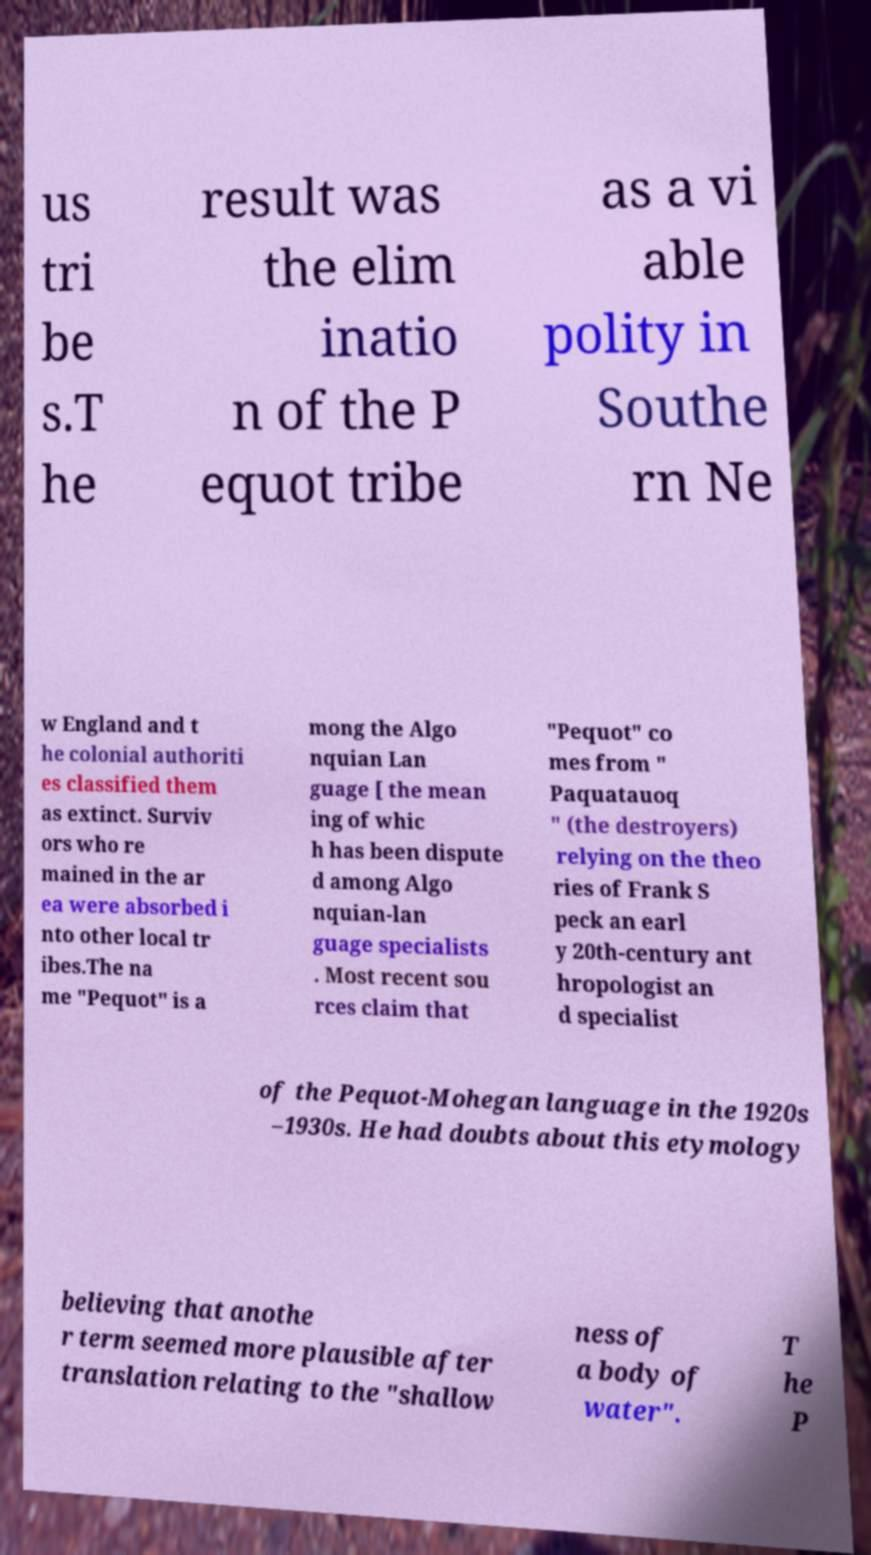There's text embedded in this image that I need extracted. Can you transcribe it verbatim? us tri be s.T he result was the elim inatio n of the P equot tribe as a vi able polity in Southe rn Ne w England and t he colonial authoriti es classified them as extinct. Surviv ors who re mained in the ar ea were absorbed i nto other local tr ibes.The na me "Pequot" is a mong the Algo nquian Lan guage [ the mean ing of whic h has been dispute d among Algo nquian-lan guage specialists . Most recent sou rces claim that "Pequot" co mes from " Paquatauoq " (the destroyers) relying on the theo ries of Frank S peck an earl y 20th-century ant hropologist an d specialist of the Pequot-Mohegan language in the 1920s –1930s. He had doubts about this etymology believing that anothe r term seemed more plausible after translation relating to the "shallow ness of a body of water". T he P 